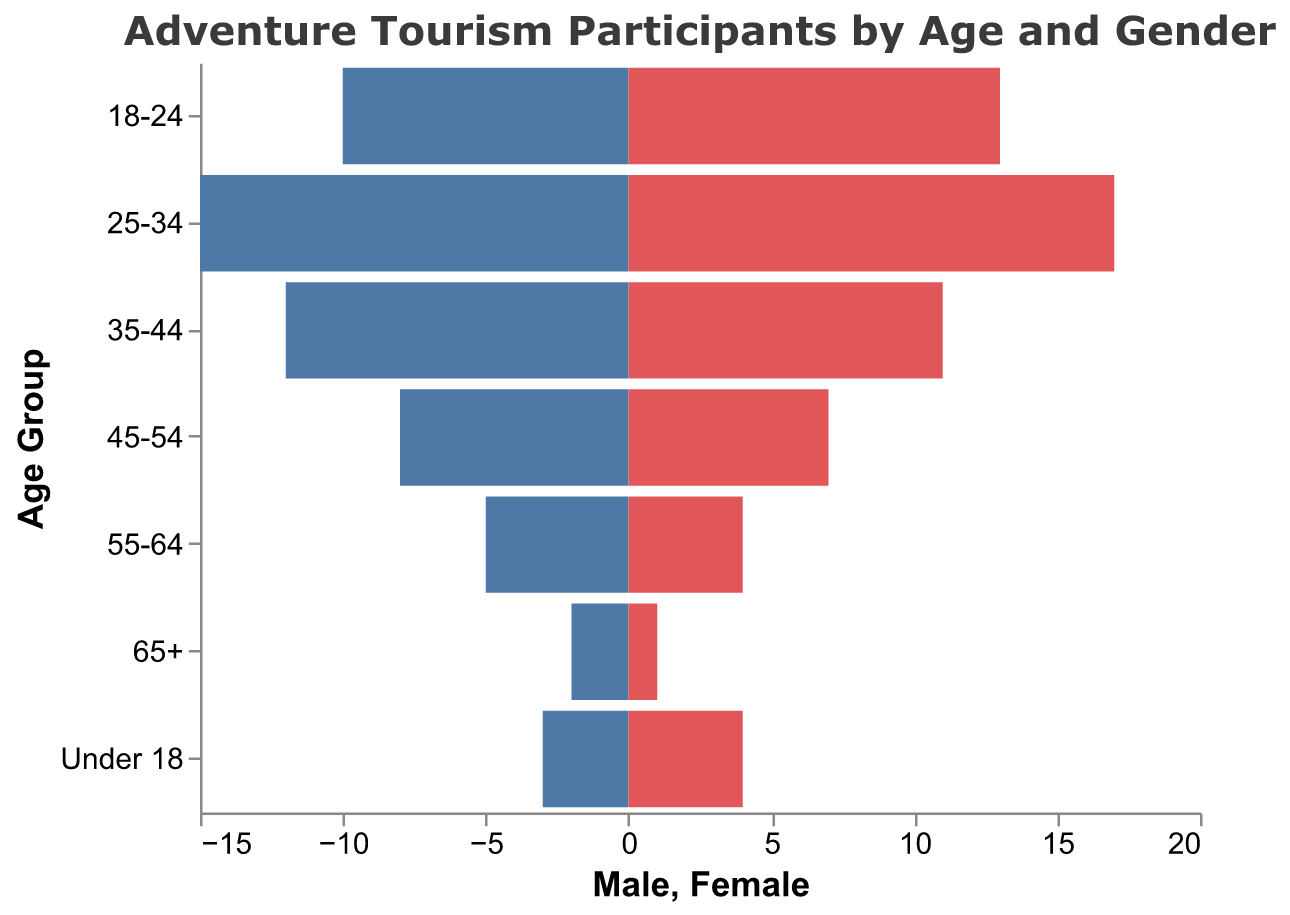Which age group has the highest number of female participants? The 25-34 age group has the highest number of female participants. By looking at the bars, the 25-34 age group has a bar that extends further out than any other age group in the Female section.
Answer: 25-34 Which age group has the fewest male participants? The 65+ age group has the fewest male participants. By comparing the lengths of the Male bars, the 65+ bar is the shortest.
Answer: 65+ What is the total number of participants in the 55-64 age group? Add the number of male and female participants in the 55-64 age group. There are 5 males and 4 females, so the total is 5 + 4.
Answer: 9 What is the age range with more female participants than male participants? Compare the lengths of the bars for males and females. The age ranges 25-34 and 18-24 have longer bars for females than for males.
Answer: 25-34, 18-24 What proportion of participants in the 35-44 age group are female? Divide the number of female participants by the total number of participants in the 35-44 age group. There are 11 females and 12 males, so the total is 11+12=23. The proportion is 11/23.
Answer: 11/23 How does the number of participants in the 18-24 age group compare to the 45-54 age group? Add up the male and female participants for each age group and compare. For the 18-24 age group: 10 males + 13 females = 23. For the 45-54 age group: 8 males + 7 females = 15.
Answer: The 18-24 age group has more participants than the 45-54 age group What is the difference between the number of male participants in the 25-34 age group compared to the 35-44 age group? Subtract the number of male participants in the 35-44 age group from the number in the 25-34 age group. There are 15 males in the 25-34 group and 12 males in the 35-44 group. The difference is 15 - 12.
Answer: 3 Which age group shows the most significant gender disparity? Calculate the absolute difference between male and female participants for each age group. The age group 25-34 has the most significant difference with 2 more females than males (17 females and 15 males).
Answer: 25-34 What percentage of the total under 18 participants are female? There are 4 female and 3 male participants under 18, which makes a total of 7. The percentage of female participants is (4/7) * 100.
Answer: ~57.1% 